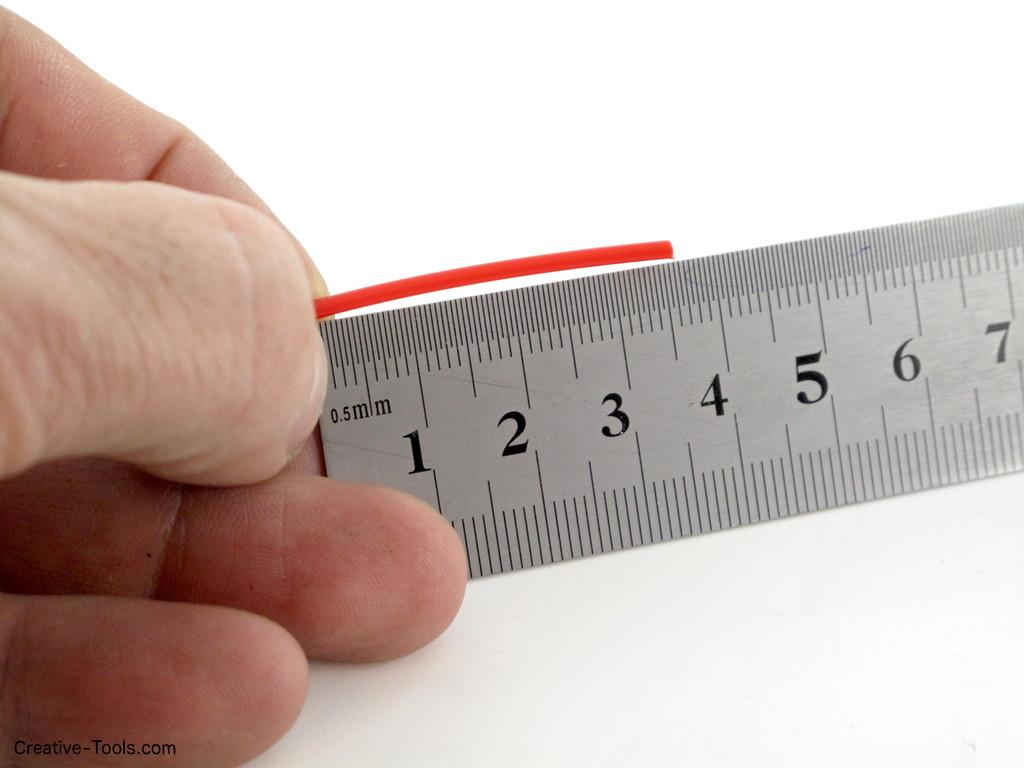<image>
Offer a succinct explanation of the picture presented. A ruler displays a 0.5 millimeter measurement at its end. 